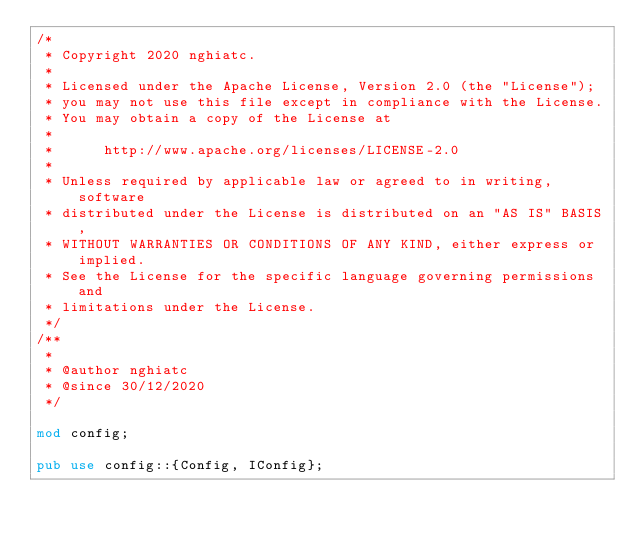Convert code to text. <code><loc_0><loc_0><loc_500><loc_500><_Rust_>/*
 * Copyright 2020 nghiatc.
 *
 * Licensed under the Apache License, Version 2.0 (the "License");
 * you may not use this file except in compliance with the License.
 * You may obtain a copy of the License at
 *
 *      http://www.apache.org/licenses/LICENSE-2.0
 *
 * Unless required by applicable law or agreed to in writing, software
 * distributed under the License is distributed on an "AS IS" BASIS,
 * WITHOUT WARRANTIES OR CONDITIONS OF ANY KIND, either express or implied.
 * See the License for the specific language governing permissions and
 * limitations under the License.
 */
/**
 *
 * @author nghiatc
 * @since 30/12/2020
 */

mod config;

pub use config::{Config, IConfig};
</code> 